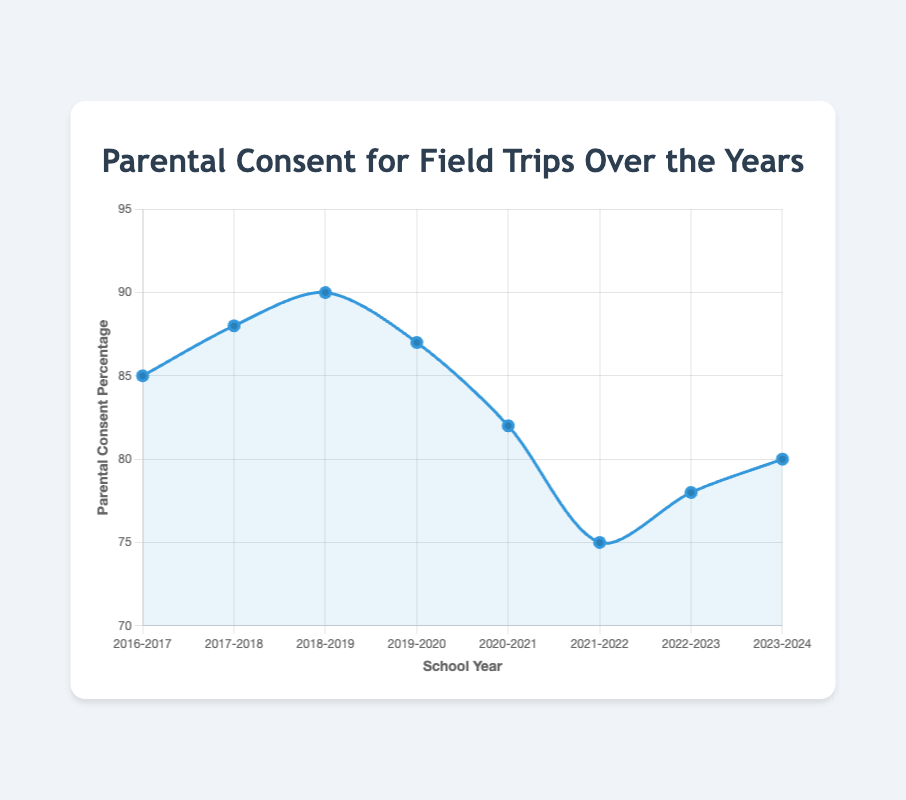What is the general trend of parental consent percentages from 2016-2024? The general trend of parental consent percentages shows fluctuations. It increased from 2016-2019, then dropped significantly in 2020 and 2021, followed by a slight recovery in 2022-2024.
Answer: Fluctuating with an overall decline Which school year had the highest parental consent percentage? By looking at the curve, the highest parental consent percentage is at the peak. For 2018-2019, it reaches 90%.
Answer: 2018-2019 Which two consecutive school years show the biggest drop in parental consent percentage? Observing the largest downward slope in the curve between two consecutive points, the biggest decline is between 2019-2020 and 2020-2021, where it drops from 87% to 82%.
Answer: 2019-2020 to 2020-2021 How does the parental consent percentage change between the school years 2017-2018 and 2020-2021? From 2017-2018 to 2020-2021, the percentages change as follows: 88% to 90% (increase), 90% to 87% (decrease), 87% to 82% (significant decrease). Summarizing the trends, an initial increase followed by two decreases.
Answer: Increase then significant decrease Is the parental consent percentage in 2023-2024 higher or lower compared to 2021-2022? Comparing the values for these two years, 2021-2022 shows 75% while 2023-2024 shows 80%, making 2023-2024 higher.
Answer: Higher What's the average parental consent percentage over the eight school years? Calculate the total percentage (85 + 88 + 90 + 87 + 82 + 75 + 78 + 80 = 665) and divide by the number of years (665 / 8).
Answer: 83.125 What notable visual pattern can be observed in the overall shape of the curve? The curve has a prominent peak in 2018-2019, followed by a sharp decline, and then a gradual rise towards the end.
Answer: Peak followed by decline and gradual rise What is the difference in parental consent percentage between the highest and lowest school years? The highest value is 90% (2018-2019) and the lowest is 75% (2021-2022). The difference is 90 - 75.
Answer: 15 During which school year did the parental consent percentage drop below 80%? The only year where the curve drops below the 80% line is 2021-2022 with 75%.
Answer: 2021-2022 What is the percentage change in parental consent from 2019-2020 to 2022-2023? Calculate the percentage change using ((78 - 87) / 87 * 100) which yields the result. First, find the difference (-9), then the percentage change is (-9/87) * 100.
Answer: -10.34 